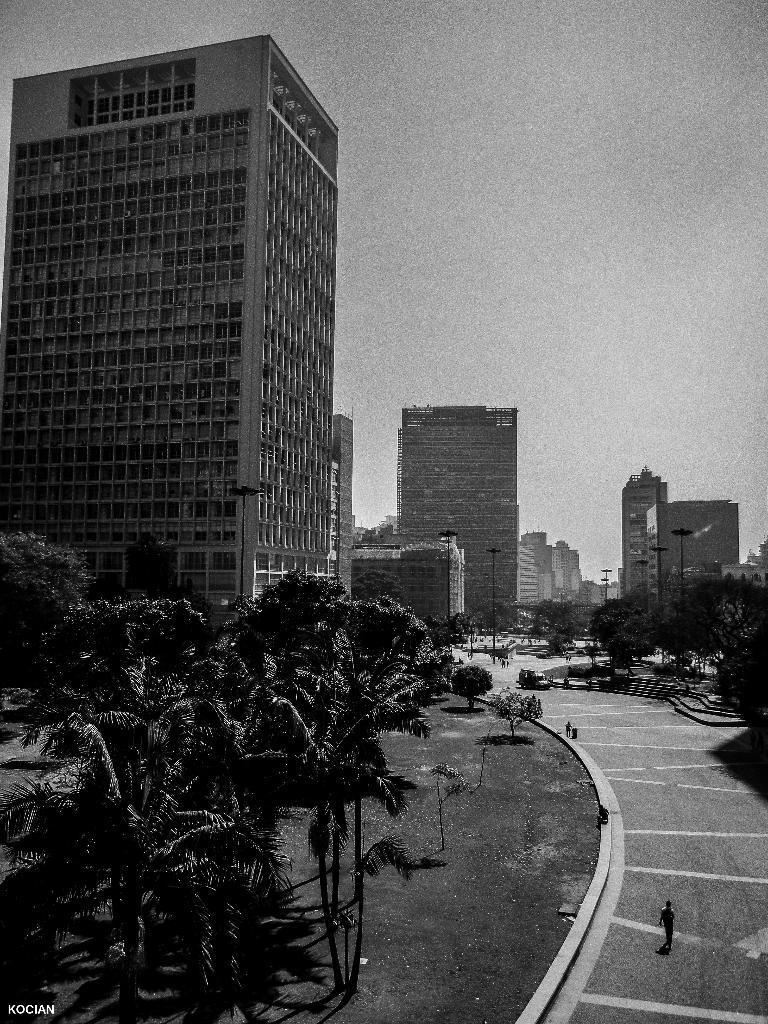Could you give a brief overview of what you see in this image? This image consists of buildings and skyscrapers. At the bottom, there is a road. To the left, there are trees. In the front, there is a person standing on the road. At the top, there is a sky. 